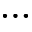<formula> <loc_0><loc_0><loc_500><loc_500>\dots</formula> 